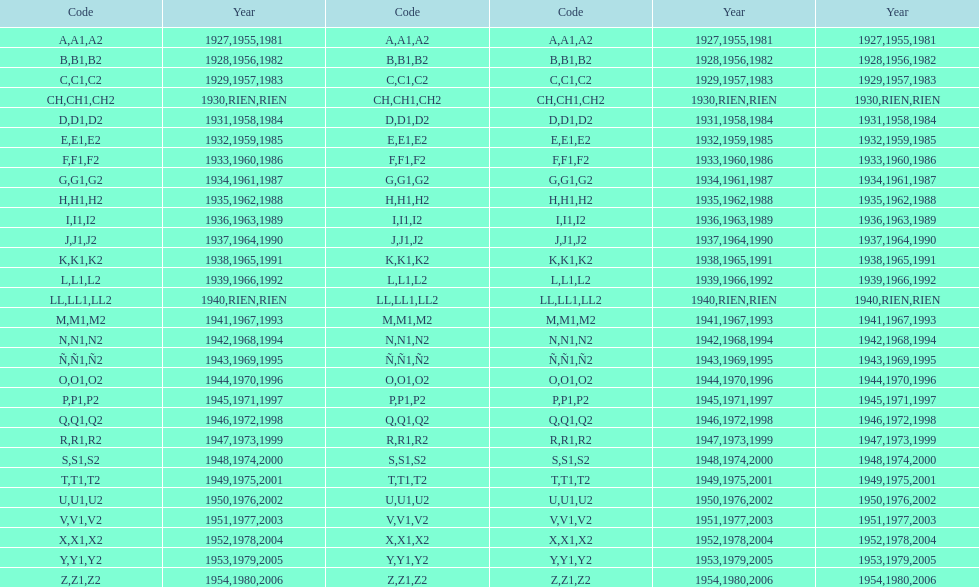Number of codes containing a 2? 28. 